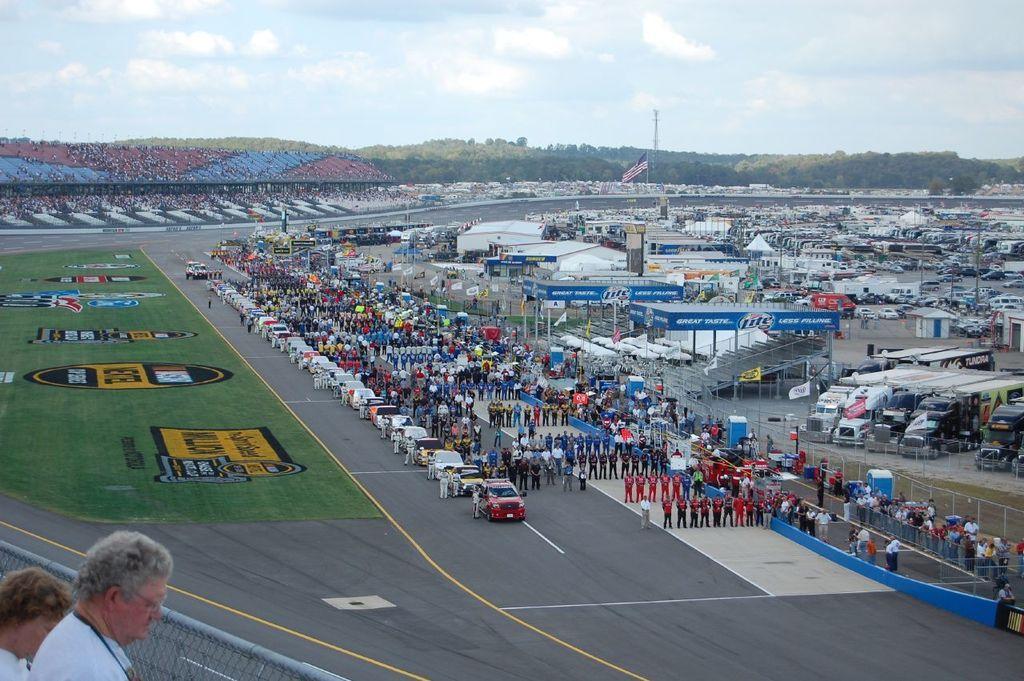In one or two sentences, can you explain what this image depicts? In this image I can see the road. On the road there are many vehicles and many people standing and wearing the different color dresses. To the right I can see many sheds, boards, vehicles and the railing. To the left I can see two people with white color dresses and these people are in-front of the railing. In the background I can see few more people, flag, many trees, clouds and the sky. 